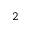<formula> <loc_0><loc_0><loc_500><loc_500>^ { 2 }</formula> 